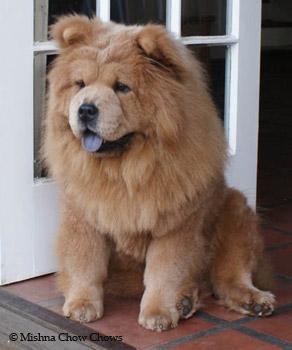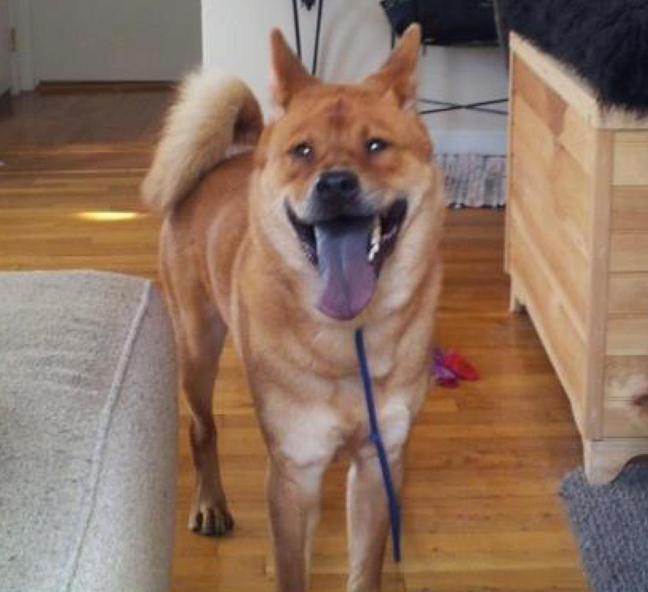The first image is the image on the left, the second image is the image on the right. For the images shown, is this caption "The dog in the right image is attached to a purple leash." true? Answer yes or no. Yes. The first image is the image on the left, the second image is the image on the right. Assess this claim about the two images: "Right image shows a standing chow dog, and left image shows a different breed of dog standing.". Correct or not? Answer yes or no. No. 